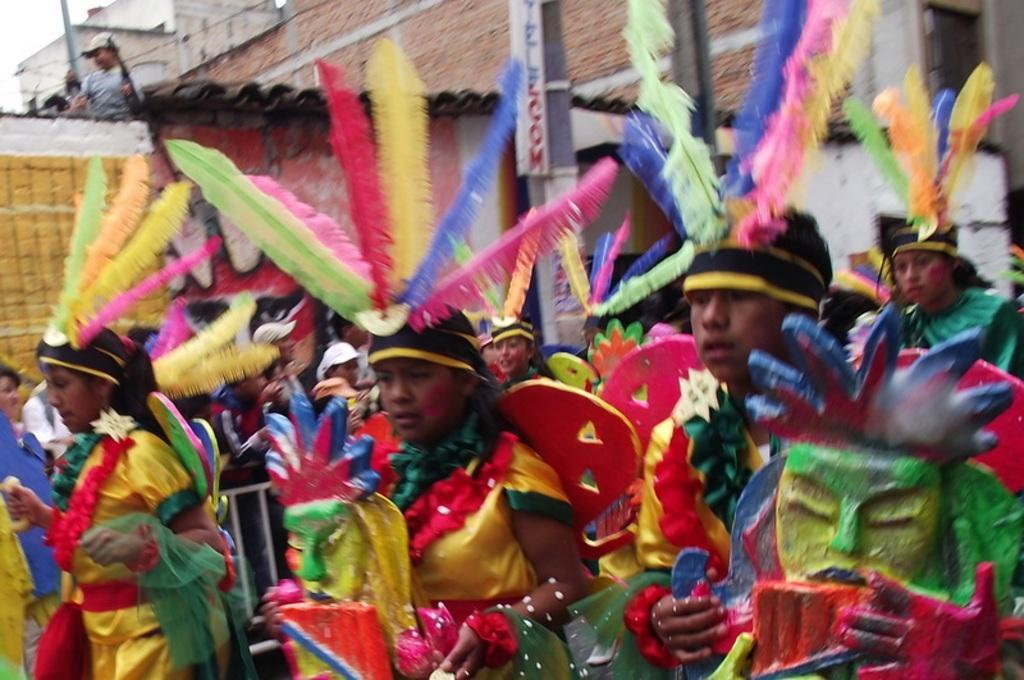Can you describe this image briefly? In this picture I can see some people are wearing different costume and dancing, side we can see people are standing on the building and watching. 